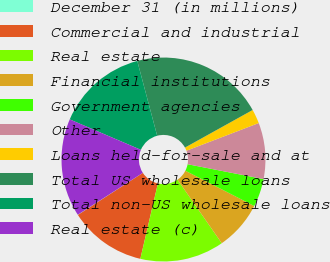Convert chart to OTSL. <chart><loc_0><loc_0><loc_500><loc_500><pie_chart><fcel>December 31 (in millions)<fcel>Commercial and industrial<fcel>Real estate<fcel>Financial institutions<fcel>Government agencies<fcel>Other<fcel>Loans held-for-sale and at<fcel>Total US wholesale loans<fcel>Total non-US wholesale loans<fcel>Real estate (c)<nl><fcel>0.04%<fcel>12.21%<fcel>13.32%<fcel>7.79%<fcel>4.46%<fcel>8.89%<fcel>2.25%<fcel>21.07%<fcel>14.43%<fcel>15.54%<nl></chart> 